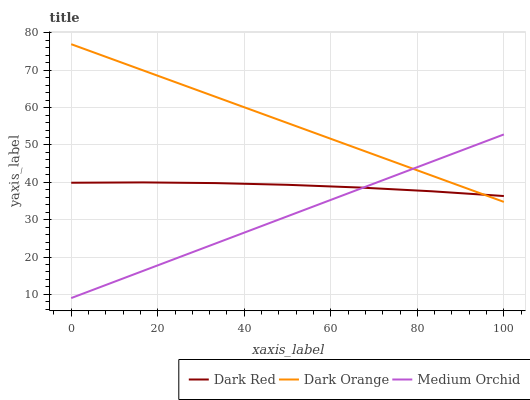Does Dark Orange have the minimum area under the curve?
Answer yes or no. No. Does Medium Orchid have the maximum area under the curve?
Answer yes or no. No. Is Medium Orchid the smoothest?
Answer yes or no. No. Is Medium Orchid the roughest?
Answer yes or no. No. Does Dark Orange have the lowest value?
Answer yes or no. No. Does Medium Orchid have the highest value?
Answer yes or no. No. 